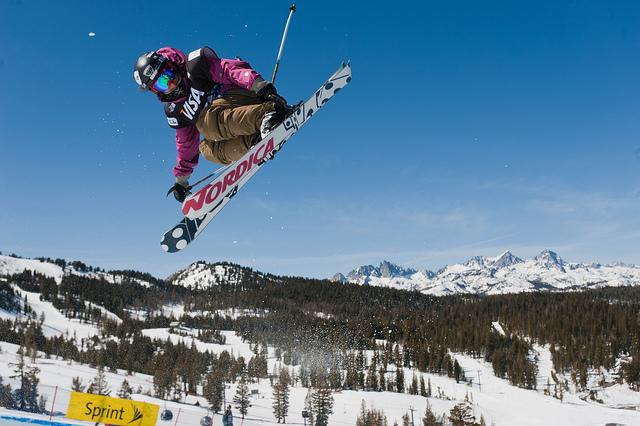What is the girl in pink doing?
Quick response, please. Skiing. Who is sponsoring the athlete?
Write a very short answer. Sprint. Why does the skier have his knees bent?
Answer briefly. Jumping. How many mountains are in this scene?
Quick response, please. 4. What color is the underside of the snowboard?
Concise answer only. White. How many feet has this person jumped in the air?
Give a very brief answer. 20. What sport is this woman partaking in?
Quick response, please. Skiing. What color is his goggles?
Keep it brief. Blue. What color is the flag?
Be succinct. Yellow. What color is the snowboard?
Quick response, please. White. What logo is on the photo?
Write a very short answer. Nordica. 